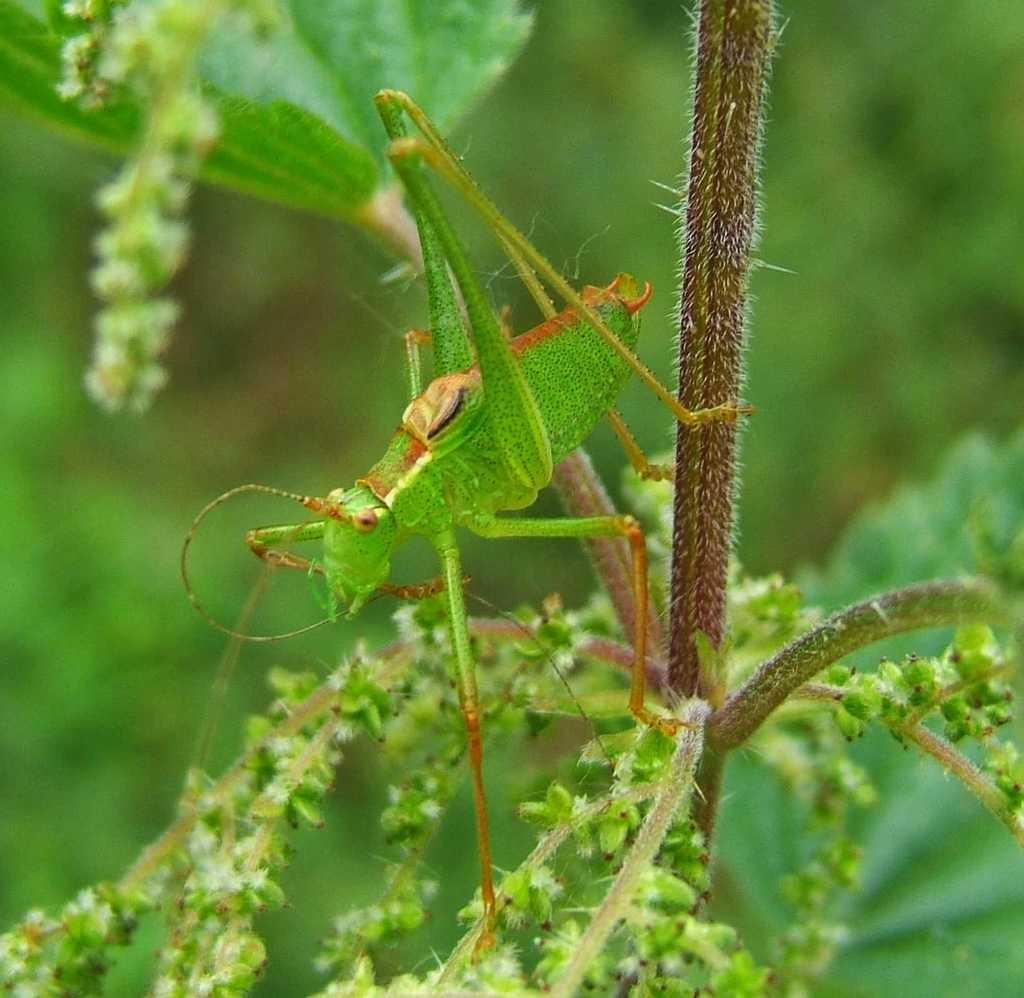What is the main subject of the image? There is a grasshopper in the image. Where is the grasshopper located? The grasshopper is on a plant. Can you describe the background of the image? The background of the image is blurred. How does the grasshopper say good-bye to the other insects in the image? There are no other insects present in the image, and grasshoppers do not have the ability to say good-bye. 